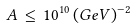Convert formula to latex. <formula><loc_0><loc_0><loc_500><loc_500>A \, \leq \, 1 0 ^ { 1 0 } \, ( G e V ) ^ { - 2 }</formula> 